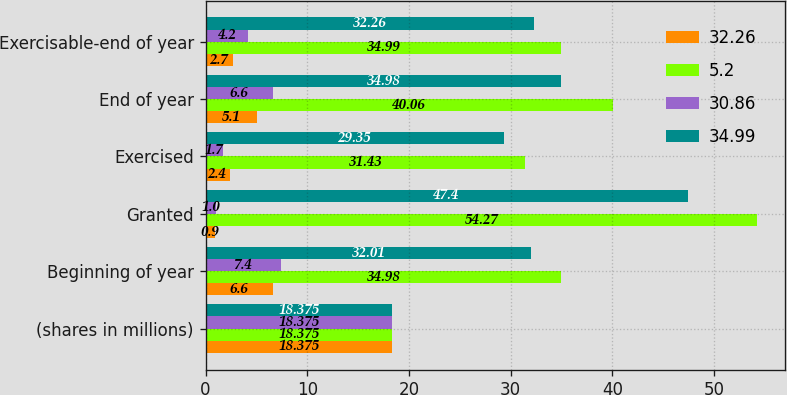<chart> <loc_0><loc_0><loc_500><loc_500><stacked_bar_chart><ecel><fcel>(shares in millions)<fcel>Beginning of year<fcel>Granted<fcel>Exercised<fcel>End of year<fcel>Exercisable-end of year<nl><fcel>32.26<fcel>18.375<fcel>6.6<fcel>0.9<fcel>2.4<fcel>5.1<fcel>2.7<nl><fcel>5.2<fcel>18.375<fcel>34.98<fcel>54.27<fcel>31.43<fcel>40.06<fcel>34.99<nl><fcel>30.86<fcel>18.375<fcel>7.4<fcel>1<fcel>1.7<fcel>6.6<fcel>4.2<nl><fcel>34.99<fcel>18.375<fcel>32.01<fcel>47.4<fcel>29.35<fcel>34.98<fcel>32.26<nl></chart> 